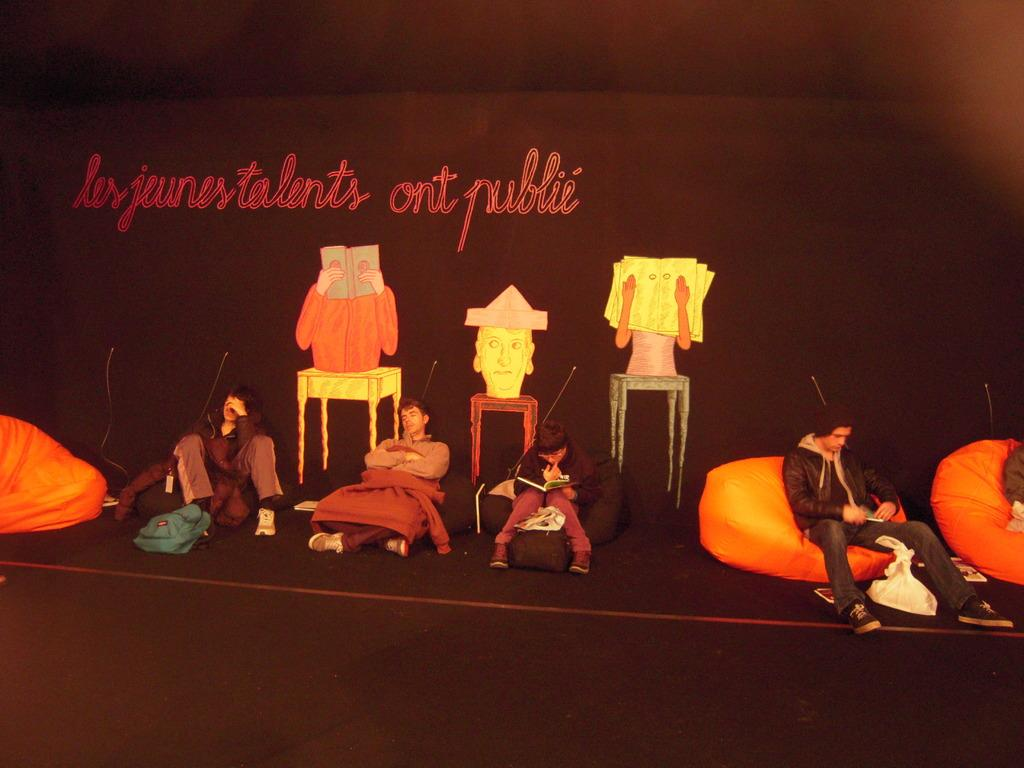What are the people sitting on in the image? The people are sitting on bean bags. What can be found on the floor in the image? There are bags, covers, and other objects on the floor. Can you describe the text in the image? There is text on a black surface. How many cars can be seen in the image? There are no cars present in the image. Is there a dog visible in the image? There is no dog present in the image. 